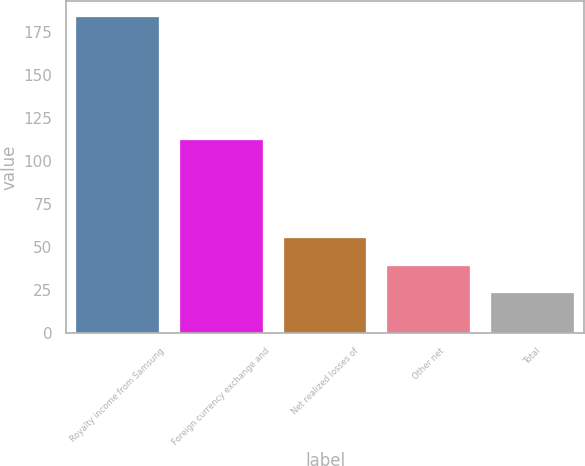<chart> <loc_0><loc_0><loc_500><loc_500><bar_chart><fcel>Royalty income from Samsung<fcel>Foreign currency exchange and<fcel>Net realized losses of<fcel>Other net<fcel>Total<nl><fcel>184<fcel>112<fcel>55.2<fcel>39.1<fcel>23<nl></chart> 